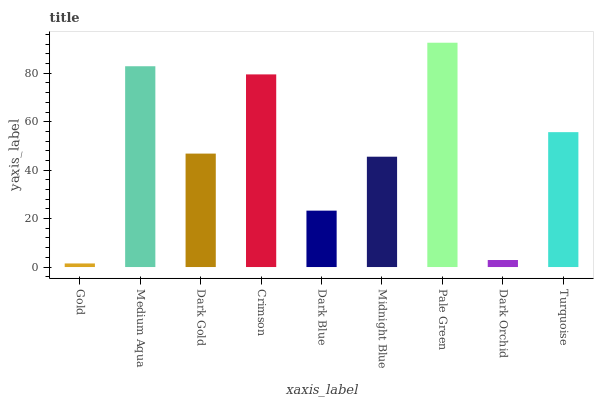Is Gold the minimum?
Answer yes or no. Yes. Is Pale Green the maximum?
Answer yes or no. Yes. Is Medium Aqua the minimum?
Answer yes or no. No. Is Medium Aqua the maximum?
Answer yes or no. No. Is Medium Aqua greater than Gold?
Answer yes or no. Yes. Is Gold less than Medium Aqua?
Answer yes or no. Yes. Is Gold greater than Medium Aqua?
Answer yes or no. No. Is Medium Aqua less than Gold?
Answer yes or no. No. Is Dark Gold the high median?
Answer yes or no. Yes. Is Dark Gold the low median?
Answer yes or no. Yes. Is Pale Green the high median?
Answer yes or no. No. Is Dark Blue the low median?
Answer yes or no. No. 